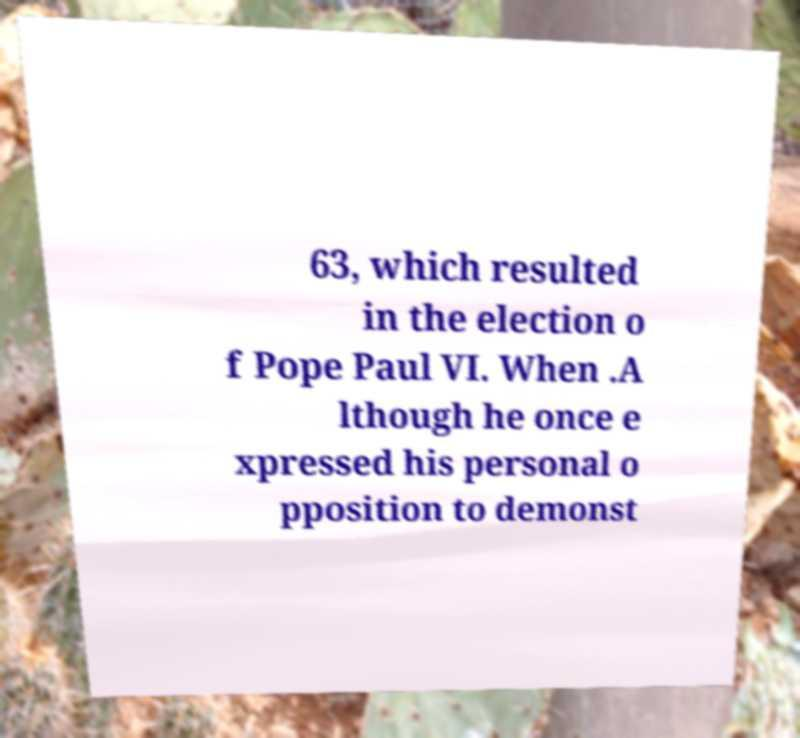Can you read and provide the text displayed in the image?This photo seems to have some interesting text. Can you extract and type it out for me? 63, which resulted in the election o f Pope Paul VI. When .A lthough he once e xpressed his personal o pposition to demonst 